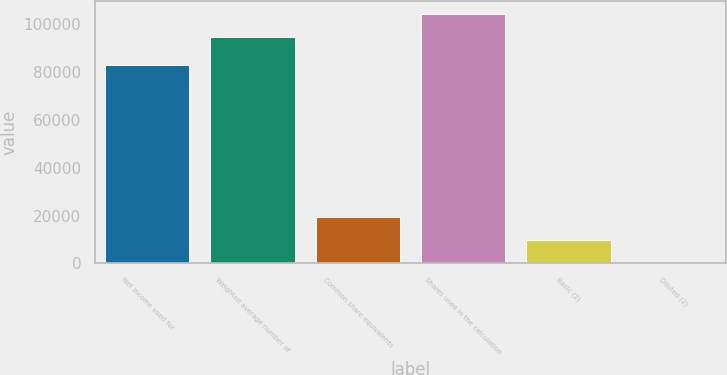Convert chart to OTSL. <chart><loc_0><loc_0><loc_500><loc_500><bar_chart><fcel>Net income used for<fcel>Weighted average number of<fcel>Common share equivalents<fcel>Shares used in the calculation<fcel>Basic (2)<fcel>Diluted (2)<nl><fcel>82964<fcel>94658<fcel>19510.5<fcel>104413<fcel>9755.67<fcel>0.85<nl></chart> 